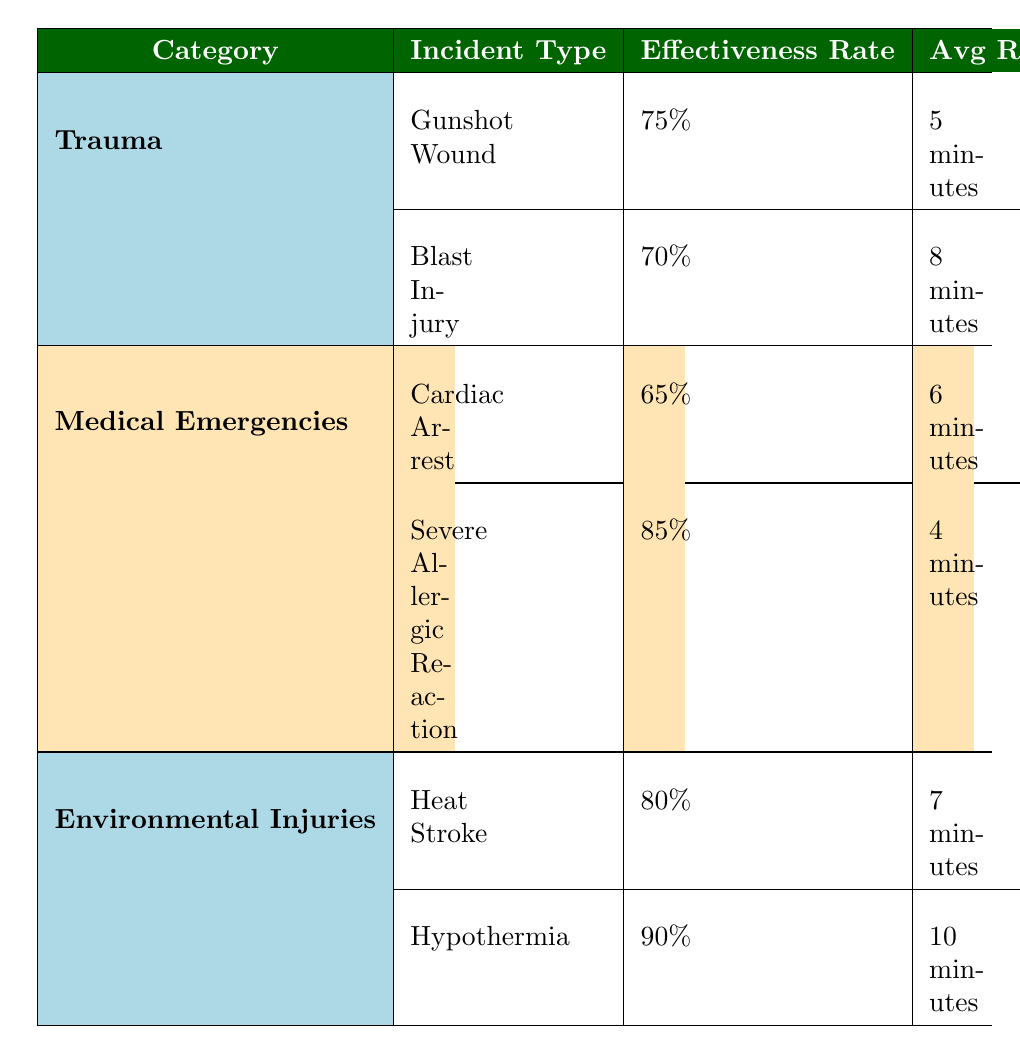What's the effectiveness rate for a Gunshot Wound? According to the table, the effectiveness rate for Gunshot Wound is listed under the Trauma category. The effectiveness rate shown for this incident type is 75%.
Answer: 75% What is the average response time for Severe Allergic Reaction? The table lists the average response time for Severe Allergic Reaction under the Medical Emergencies category, showing it is 4 minutes.
Answer: 4 minutes Which incident type has the highest effectiveness rate? To find the incident type with the highest effectiveness rate, we compare all effectiveness rates: Gunshot Wound (75%), Blast Injury (70%), Cardiac Arrest (65%), Severe Allergic Reaction (85%), Heat Stroke (80%), and Hypothermia (90%). The highest is 90% for Hypothermia.
Answer: Hypothermia Are cooling measures common procedures for Heat Stroke? Checking the table, "Cooling Measures" is indeed listed as one of the common procedures for Heat Stroke under Environmental Injuries. Thus, the answer is yes.
Answer: Yes What is the difference in effectiveness rates between Severe Allergic Reaction and Cardiac Arrest? The effectiveness rate for Severe Allergic Reaction is 85%, and for Cardiac Arrest, it is 65%. The difference can be calculated as 85% - 65% = 20%. Thus, the difference in effectiveness rates is 20%.
Answer: 20% Which incident type has the longest average response time? We review the average response times of all incident types: Gunshot Wound (5 minutes), Blast Injury (8 minutes), Cardiac Arrest (6 minutes), Severe Allergic Reaction (4 minutes), Heat Stroke (7 minutes), and Hypothermia (10 minutes). The longest time is 10 minutes for Hypothermia.
Answer: Hypothermia Is the effectiveness rate for Trauma incidents generally higher than for Medical Emergencies? In the table, the effectiveness rates are listed as 75% for Gunshot Wound and 70% for Blast Injury, averaging 72.5%. For Medical Emergencies, the rates are 65% for Cardiac Arrest and 85% for Severe Allergic Reaction, averaging 75%. Since 72.5% is less than 75%, the effectiveness rates for Medical Emergencies are higher.
Answer: No What is the average effectiveness rate across all incident types? To find the average effectiveness rate, add all effectiveness rates: 75% (Gunshot Wound) + 70% (Blast Injury) + 65% (Cardiac Arrest) + 85% (Severe Allergic Reaction) + 80% (Heat Stroke) + 90% (Hypothermia) = 465%. Dividing by the number of incident types (6) gives an average of 465% / 6 = 77.5%.
Answer: 77.5% 